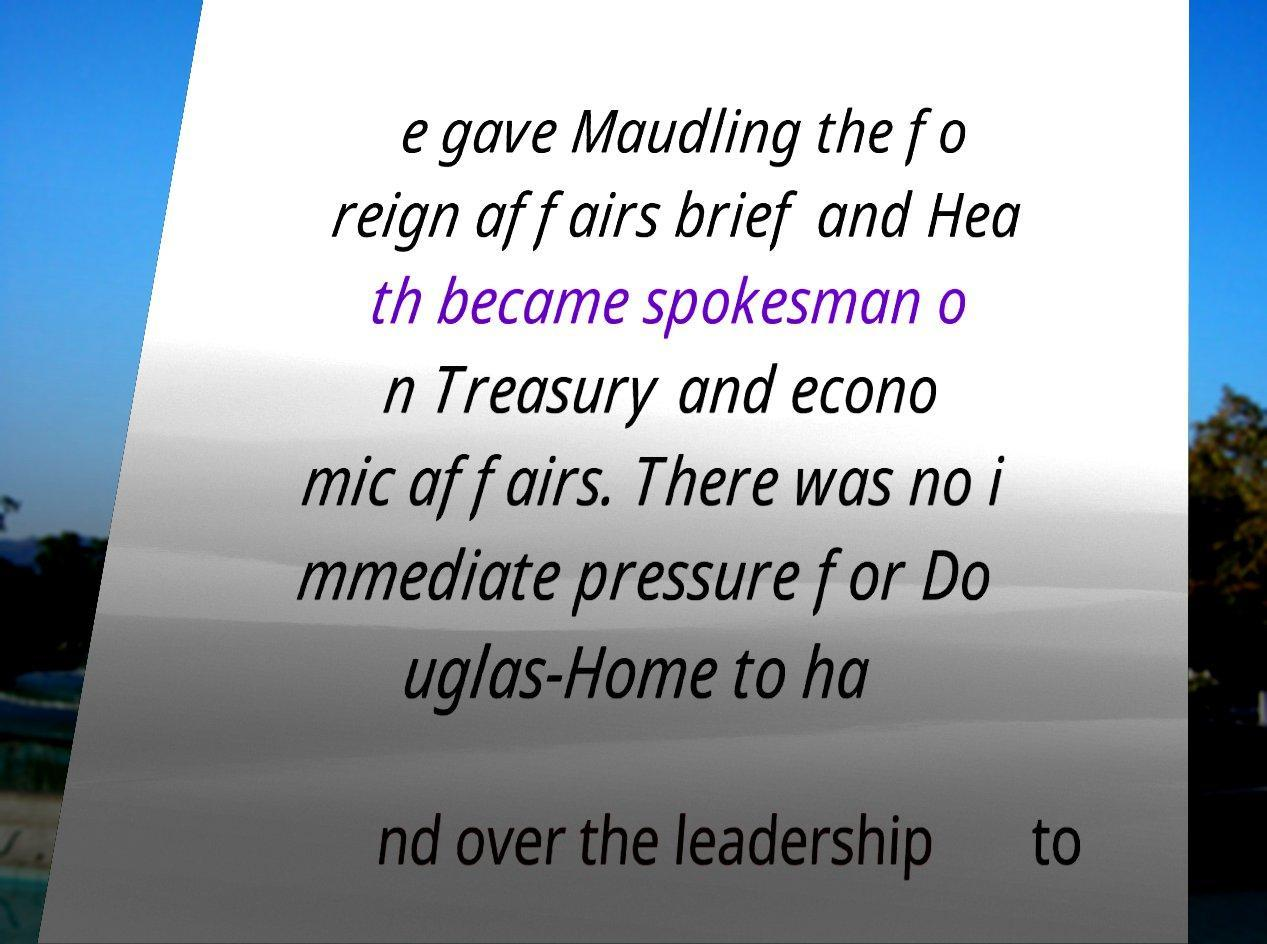Please read and relay the text visible in this image. What does it say? e gave Maudling the fo reign affairs brief and Hea th became spokesman o n Treasury and econo mic affairs. There was no i mmediate pressure for Do uglas-Home to ha nd over the leadership to 